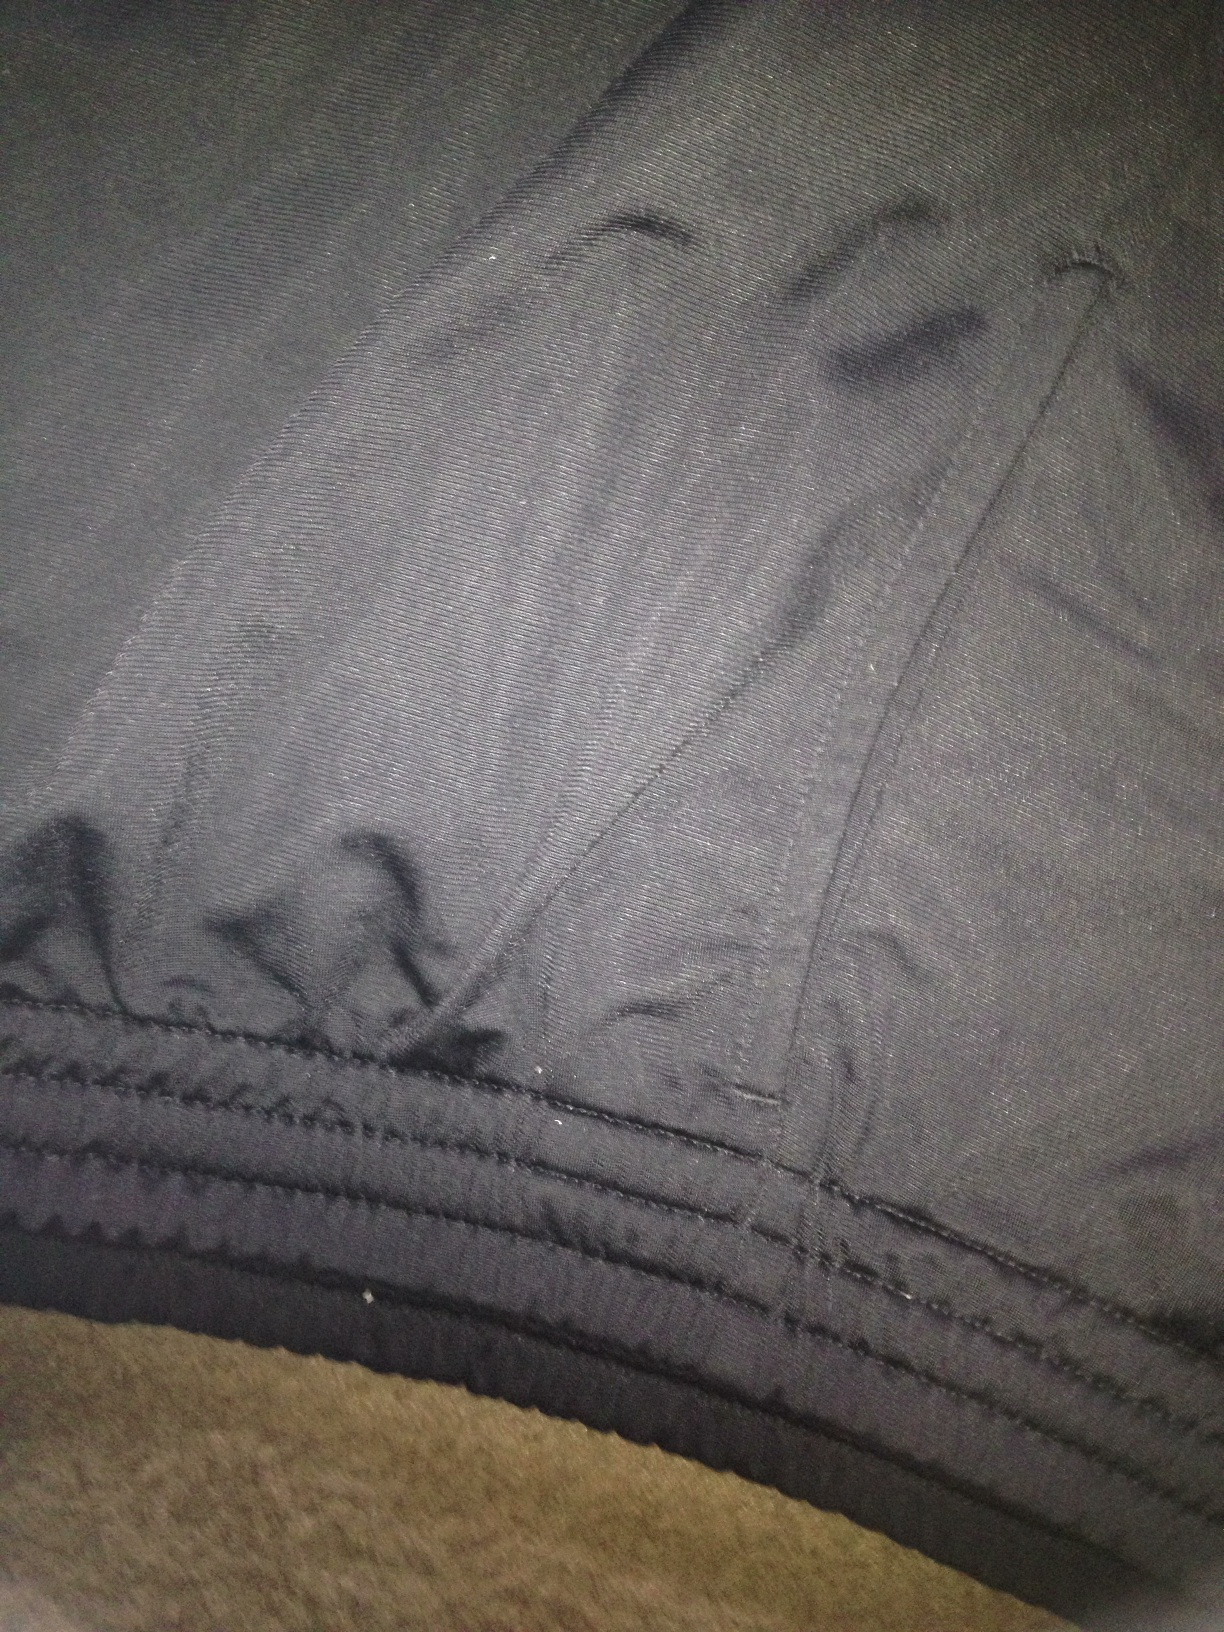Imagine these pants are part of a superhero costume. Describe the character. The hero, known as Shadow Strider, wears these grey pants as part of his stealth suit. Designed for agility and speed, the pants are made from a special fabric that blends into the darkness, allowing him to move unseen. With reinforced stitching for added strength, Shadow Strider fights against crime with swift, silent movements and uses the shadows as his ally. What special powers does Shadow Strider have? Shadow Strider possesses the unique ability to manipulate shadows, using them to cloak himself and meld seamlessly into his surroundings. This power enables him to move swiftly and undetected, making him a master of espionage and reconnaissance. Additionally, he can solidify shadows to create temporary physical barriers or weapons, which he skillfully employs in combat. What mission is Shadow Strider currently on? Shadow Strider's latest mission is to infiltrate the fortress of the nefarious crime lord known as the Crimson King. The Crimson King has been orchestrating a series of high-profile heists, and Shadow Strider's goal is to gather intel on the criminal's operations and sabotage his plans from within. Using his shadow manipulation skills, Shadow Strider sneaks into the compound under the cover of night, determined to bring down the Crimson King's empire from the shadows. What gear is Shadow Strider equipped with? Shadow Strider's gear includes his signature suit made of an advanced, shadow-woven fabric that enhances his ability to blend into the darkness. He carries a set of versatile shadow blades, which can be solidified from shadows at will, and a grappling hook gun for swift vertical movements. His utility belt contains various high-tech gadgets, such as smoke bombs, EMP devices, and a compact, handheld computer for hacking security systems. Additionally, his mask is equipped with night vision and facial recognition technology, further enhancing his stealth capabilities. 